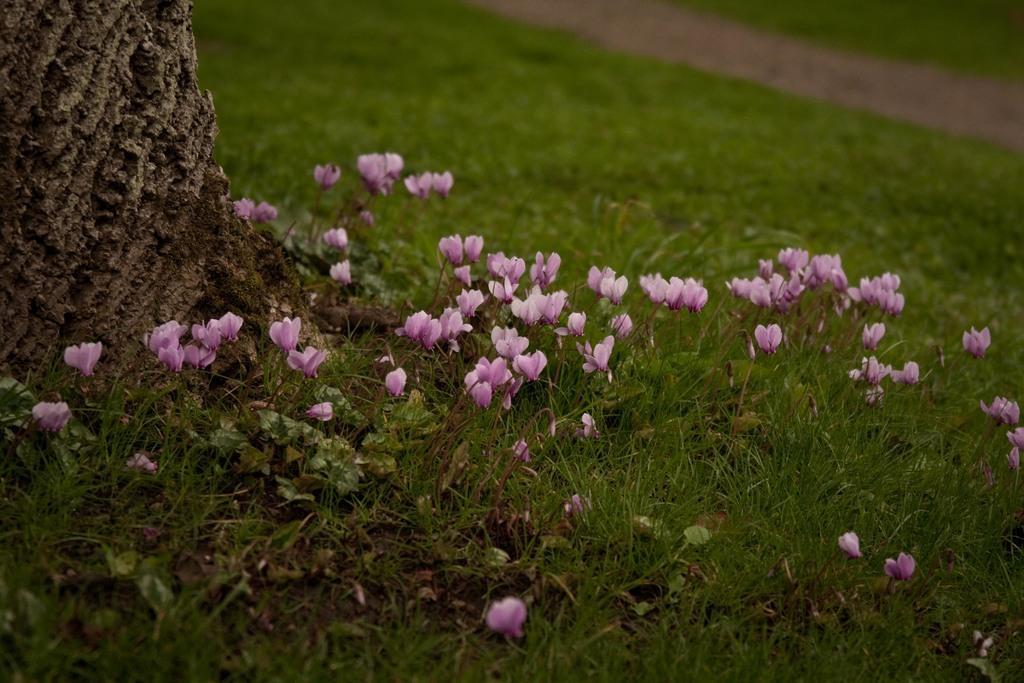Describe this image in one or two sentences. In this image there is grass and having few plants which are having few flowers to it. Right top there is a path in between the grassland. Left side there is a tree trunk. 